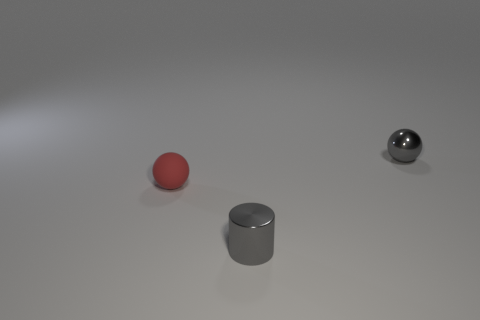What shape is the tiny shiny thing that is the same color as the small metal cylinder?
Provide a short and direct response. Sphere. Does the shiny object on the right side of the small gray metal cylinder have the same color as the cylinder?
Provide a succinct answer. Yes. There is a small sphere that is on the right side of the gray shiny cylinder; what is it made of?
Your answer should be compact. Metal. Are the gray thing that is right of the small gray metallic cylinder and the red ball made of the same material?
Provide a short and direct response. No. Is there anything else that is the same color as the small cylinder?
Give a very brief answer. Yes. How many tiny things are behind the gray shiny cylinder and on the right side of the tiny matte thing?
Your answer should be compact. 1. Is there another small thing of the same shape as the rubber object?
Give a very brief answer. Yes. What is the shape of the rubber object that is the same size as the gray metallic cylinder?
Offer a very short reply. Sphere. Is the number of small gray shiny balls that are in front of the gray metal cylinder the same as the number of tiny shiny objects behind the gray sphere?
Your answer should be very brief. Yes. Are there any gray things that have the same size as the red object?
Keep it short and to the point. Yes. 